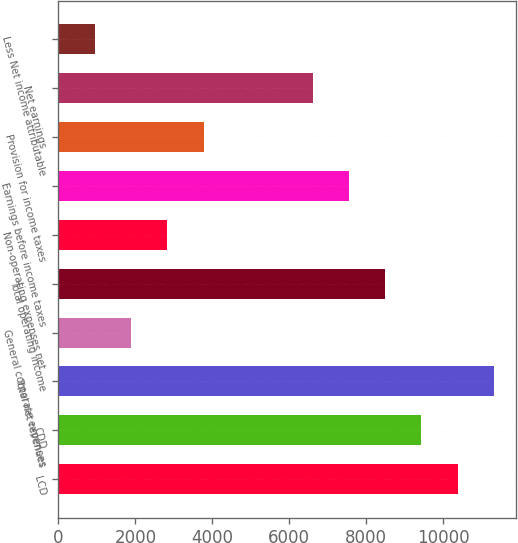Convert chart to OTSL. <chart><loc_0><loc_0><loc_500><loc_500><bar_chart><fcel>LCD<fcel>CDD<fcel>Total net revenues<fcel>General corporate expenses<fcel>Total operating income<fcel>Non-operating expenses net<fcel>Earnings before income taxes<fcel>Provision for income taxes<fcel>Net earnings<fcel>Less Net income attributable<nl><fcel>10380.9<fcel>9437.2<fcel>11324.6<fcel>1887.52<fcel>8493.49<fcel>2831.23<fcel>7549.78<fcel>3774.94<fcel>6606.07<fcel>943.81<nl></chart> 